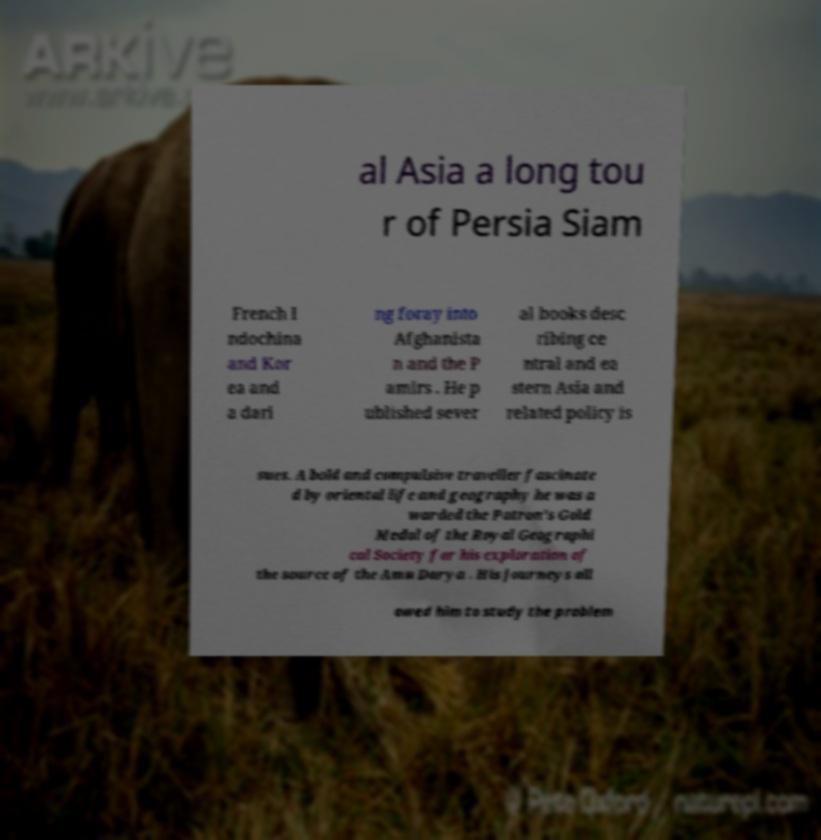Can you accurately transcribe the text from the provided image for me? al Asia a long tou r of Persia Siam French I ndochina and Kor ea and a dari ng foray into Afghanista n and the P amirs . He p ublished sever al books desc ribing ce ntral and ea stern Asia and related policy is sues. A bold and compulsive traveller fascinate d by oriental life and geography he was a warded the Patron's Gold Medal of the Royal Geographi cal Society for his exploration of the source of the Amu Darya . His journeys all owed him to study the problem 